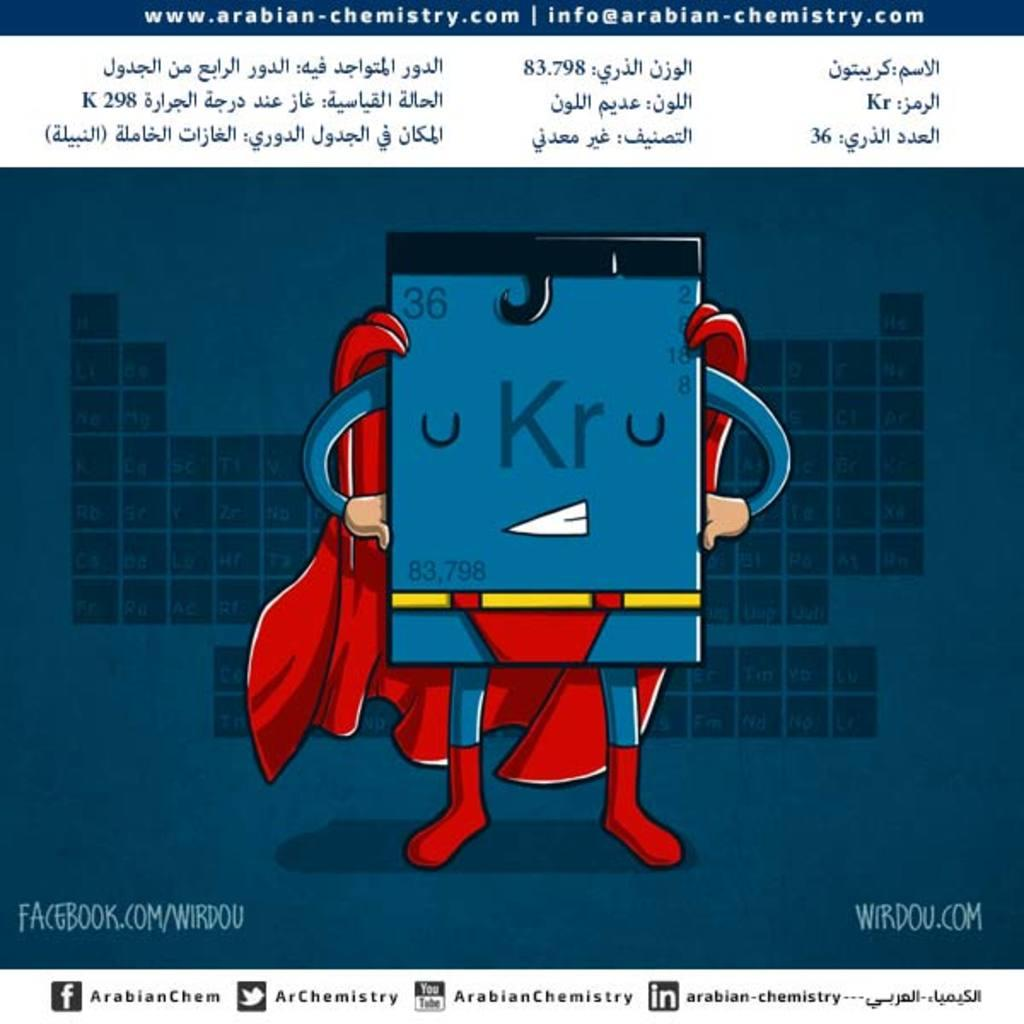What type of content is depicted in the picture? There is a cartoon in the picture. Can you describe any textual elements in the image? There is text on the top and bottom of the picture. What can be seen on the sides of the image? There are watermarks on the left and right sides of the picture. What kind of argument is taking place between the characters in the cartoon? There is no argument taking place in the cartoon; it is a still image. Can you see the moon in the image? The moon is not visible in the image; it features a cartoon and textual elements. 